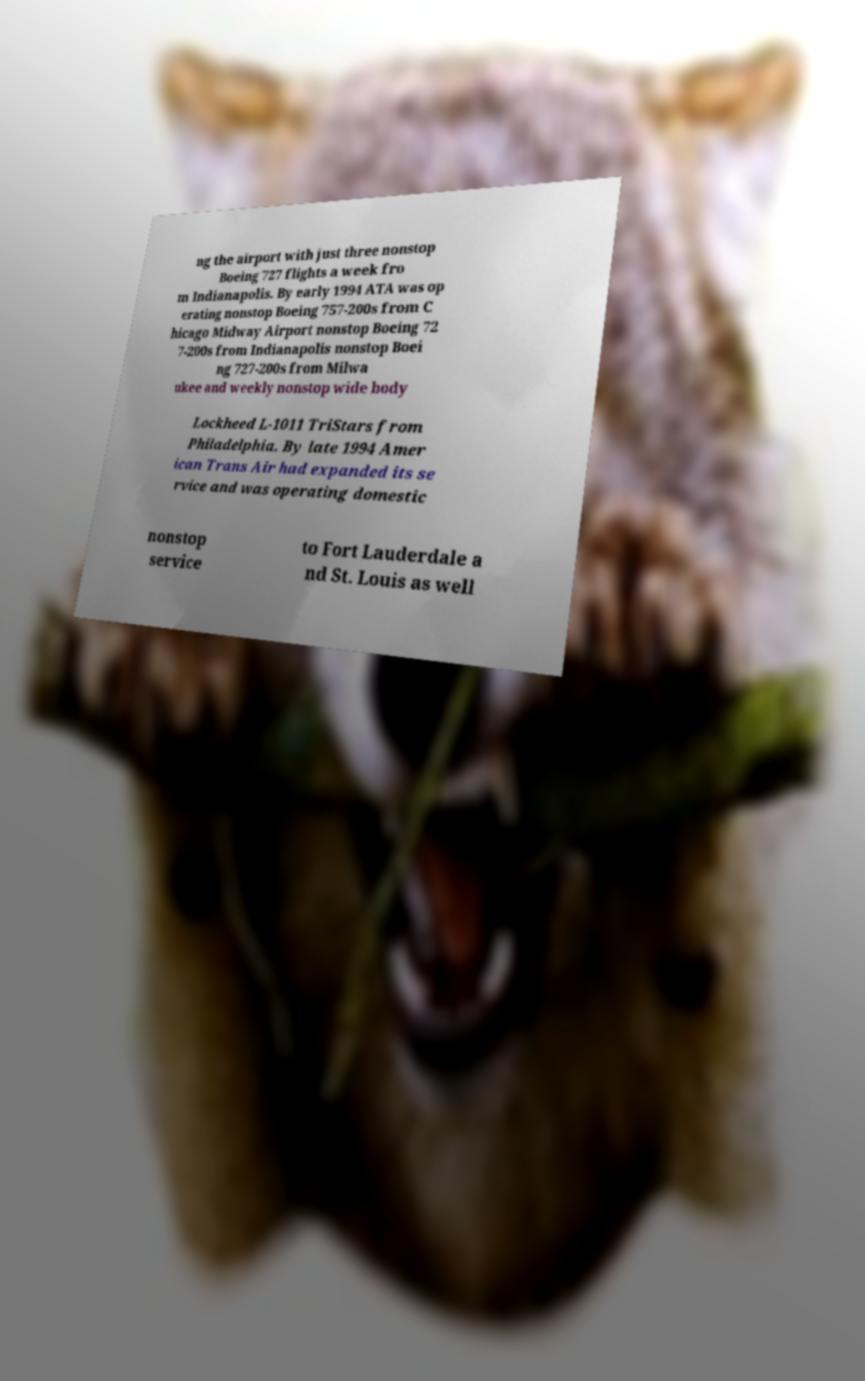Could you assist in decoding the text presented in this image and type it out clearly? ng the airport with just three nonstop Boeing 727 flights a week fro m Indianapolis. By early 1994 ATA was op erating nonstop Boeing 757-200s from C hicago Midway Airport nonstop Boeing 72 7-200s from Indianapolis nonstop Boei ng 727-200s from Milwa ukee and weekly nonstop wide body Lockheed L-1011 TriStars from Philadelphia. By late 1994 Amer ican Trans Air had expanded its se rvice and was operating domestic nonstop service to Fort Lauderdale a nd St. Louis as well 